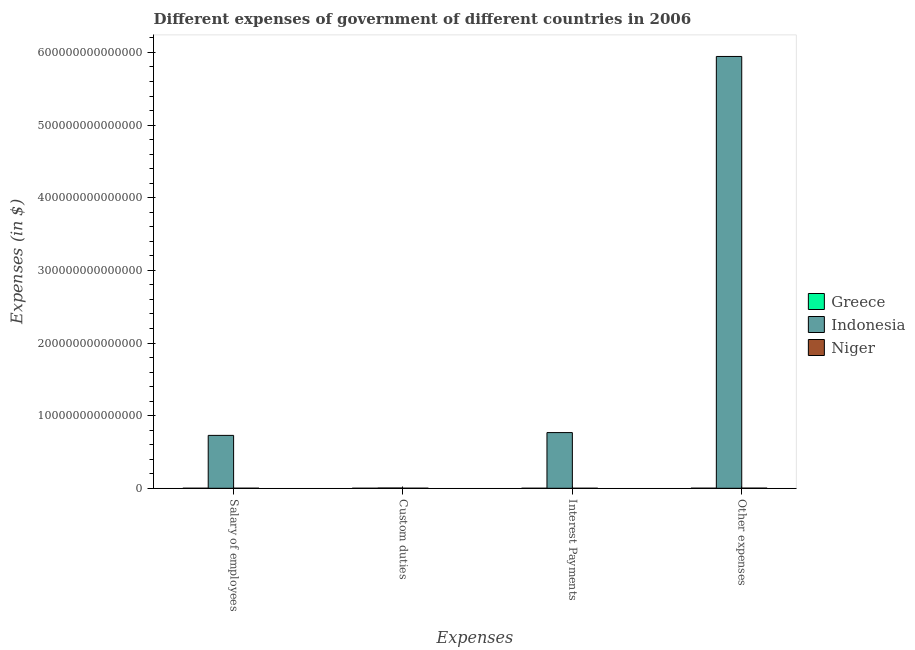How many different coloured bars are there?
Make the answer very short. 3. How many groups of bars are there?
Offer a terse response. 4. What is the label of the 2nd group of bars from the left?
Keep it short and to the point. Custom duties. What is the amount spent on salary of employees in Indonesia?
Your answer should be very brief. 7.28e+13. Across all countries, what is the maximum amount spent on other expenses?
Your answer should be compact. 5.94e+14. Across all countries, what is the minimum amount spent on custom duties?
Provide a succinct answer. 4.00e+06. In which country was the amount spent on other expenses maximum?
Offer a terse response. Indonesia. What is the total amount spent on interest payments in the graph?
Provide a short and direct response. 7.67e+13. What is the difference between the amount spent on interest payments in Greece and that in Niger?
Ensure brevity in your answer.  -1.00e+09. What is the difference between the amount spent on custom duties in Indonesia and the amount spent on salary of employees in Greece?
Ensure brevity in your answer.  3.24e+11. What is the average amount spent on other expenses per country?
Give a very brief answer. 1.98e+14. What is the difference between the amount spent on other expenses and amount spent on custom duties in Indonesia?
Ensure brevity in your answer.  5.94e+14. What is the ratio of the amount spent on custom duties in Greece to that in Indonesia?
Offer a very short reply. 1.1603900029885854e-5. Is the amount spent on custom duties in Indonesia less than that in Niger?
Your answer should be very brief. No. What is the difference between the highest and the second highest amount spent on other expenses?
Give a very brief answer. 5.94e+14. What is the difference between the highest and the lowest amount spent on interest payments?
Ensure brevity in your answer.  7.67e+13. What does the 3rd bar from the left in Interest Payments represents?
Offer a very short reply. Niger. What does the 3rd bar from the right in Salary of employees represents?
Your answer should be compact. Greece. How many bars are there?
Your response must be concise. 12. How many countries are there in the graph?
Keep it short and to the point. 3. What is the difference between two consecutive major ticks on the Y-axis?
Give a very brief answer. 1.00e+14. Are the values on the major ticks of Y-axis written in scientific E-notation?
Your answer should be compact. No. Does the graph contain grids?
Your answer should be compact. No. How many legend labels are there?
Give a very brief answer. 3. What is the title of the graph?
Your response must be concise. Different expenses of government of different countries in 2006. What is the label or title of the X-axis?
Offer a terse response. Expenses. What is the label or title of the Y-axis?
Provide a short and direct response. Expenses (in $). What is the Expenses (in $) in Greece in Salary of employees?
Make the answer very short. 2.10e+1. What is the Expenses (in $) of Indonesia in Salary of employees?
Ensure brevity in your answer.  7.28e+13. What is the Expenses (in $) in Niger in Salary of employees?
Give a very brief answer. 6.80e+1. What is the Expenses (in $) of Greece in Custom duties?
Your response must be concise. 4.00e+06. What is the Expenses (in $) in Indonesia in Custom duties?
Your answer should be compact. 3.45e+11. What is the Expenses (in $) of Niger in Custom duties?
Offer a very short reply. 8.34e+1. What is the Expenses (in $) in Greece in Interest Payments?
Ensure brevity in your answer.  9.73e+09. What is the Expenses (in $) in Indonesia in Interest Payments?
Make the answer very short. 7.67e+13. What is the Expenses (in $) of Niger in Interest Payments?
Offer a very short reply. 1.07e+1. What is the Expenses (in $) of Greece in Other expenses?
Your answer should be very brief. 8.96e+1. What is the Expenses (in $) in Indonesia in Other expenses?
Ensure brevity in your answer.  5.94e+14. What is the Expenses (in $) of Niger in Other expenses?
Make the answer very short. 1.77e+11. Across all Expenses, what is the maximum Expenses (in $) of Greece?
Make the answer very short. 8.96e+1. Across all Expenses, what is the maximum Expenses (in $) in Indonesia?
Your answer should be very brief. 5.94e+14. Across all Expenses, what is the maximum Expenses (in $) of Niger?
Your answer should be compact. 1.77e+11. Across all Expenses, what is the minimum Expenses (in $) of Greece?
Provide a succinct answer. 4.00e+06. Across all Expenses, what is the minimum Expenses (in $) in Indonesia?
Ensure brevity in your answer.  3.45e+11. Across all Expenses, what is the minimum Expenses (in $) in Niger?
Your response must be concise. 1.07e+1. What is the total Expenses (in $) in Greece in the graph?
Your answer should be compact. 1.20e+11. What is the total Expenses (in $) in Indonesia in the graph?
Your answer should be very brief. 7.44e+14. What is the total Expenses (in $) of Niger in the graph?
Offer a very short reply. 3.39e+11. What is the difference between the Expenses (in $) in Greece in Salary of employees and that in Custom duties?
Your response must be concise. 2.10e+1. What is the difference between the Expenses (in $) in Indonesia in Salary of employees and that in Custom duties?
Offer a terse response. 7.25e+13. What is the difference between the Expenses (in $) of Niger in Salary of employees and that in Custom duties?
Your answer should be compact. -1.54e+1. What is the difference between the Expenses (in $) in Greece in Salary of employees and that in Interest Payments?
Provide a succinct answer. 1.13e+1. What is the difference between the Expenses (in $) of Indonesia in Salary of employees and that in Interest Payments?
Make the answer very short. -3.85e+12. What is the difference between the Expenses (in $) in Niger in Salary of employees and that in Interest Payments?
Offer a terse response. 5.72e+1. What is the difference between the Expenses (in $) in Greece in Salary of employees and that in Other expenses?
Keep it short and to the point. -6.86e+1. What is the difference between the Expenses (in $) of Indonesia in Salary of employees and that in Other expenses?
Your answer should be compact. -5.22e+14. What is the difference between the Expenses (in $) of Niger in Salary of employees and that in Other expenses?
Ensure brevity in your answer.  -1.09e+11. What is the difference between the Expenses (in $) in Greece in Custom duties and that in Interest Payments?
Your answer should be compact. -9.72e+09. What is the difference between the Expenses (in $) in Indonesia in Custom duties and that in Interest Payments?
Ensure brevity in your answer.  -7.63e+13. What is the difference between the Expenses (in $) of Niger in Custom duties and that in Interest Payments?
Offer a very short reply. 7.27e+1. What is the difference between the Expenses (in $) in Greece in Custom duties and that in Other expenses?
Your answer should be compact. -8.96e+1. What is the difference between the Expenses (in $) of Indonesia in Custom duties and that in Other expenses?
Give a very brief answer. -5.94e+14. What is the difference between the Expenses (in $) of Niger in Custom duties and that in Other expenses?
Offer a very short reply. -9.35e+1. What is the difference between the Expenses (in $) of Greece in Interest Payments and that in Other expenses?
Ensure brevity in your answer.  -7.98e+1. What is the difference between the Expenses (in $) of Indonesia in Interest Payments and that in Other expenses?
Make the answer very short. -5.18e+14. What is the difference between the Expenses (in $) of Niger in Interest Payments and that in Other expenses?
Give a very brief answer. -1.66e+11. What is the difference between the Expenses (in $) of Greece in Salary of employees and the Expenses (in $) of Indonesia in Custom duties?
Provide a short and direct response. -3.24e+11. What is the difference between the Expenses (in $) of Greece in Salary of employees and the Expenses (in $) of Niger in Custom duties?
Provide a short and direct response. -6.24e+1. What is the difference between the Expenses (in $) of Indonesia in Salary of employees and the Expenses (in $) of Niger in Custom duties?
Ensure brevity in your answer.  7.28e+13. What is the difference between the Expenses (in $) of Greece in Salary of employees and the Expenses (in $) of Indonesia in Interest Payments?
Ensure brevity in your answer.  -7.67e+13. What is the difference between the Expenses (in $) of Greece in Salary of employees and the Expenses (in $) of Niger in Interest Payments?
Offer a very short reply. 1.03e+1. What is the difference between the Expenses (in $) in Indonesia in Salary of employees and the Expenses (in $) in Niger in Interest Payments?
Make the answer very short. 7.28e+13. What is the difference between the Expenses (in $) in Greece in Salary of employees and the Expenses (in $) in Indonesia in Other expenses?
Make the answer very short. -5.94e+14. What is the difference between the Expenses (in $) in Greece in Salary of employees and the Expenses (in $) in Niger in Other expenses?
Provide a succinct answer. -1.56e+11. What is the difference between the Expenses (in $) of Indonesia in Salary of employees and the Expenses (in $) of Niger in Other expenses?
Make the answer very short. 7.27e+13. What is the difference between the Expenses (in $) in Greece in Custom duties and the Expenses (in $) in Indonesia in Interest Payments?
Offer a very short reply. -7.67e+13. What is the difference between the Expenses (in $) in Greece in Custom duties and the Expenses (in $) in Niger in Interest Payments?
Offer a terse response. -1.07e+1. What is the difference between the Expenses (in $) of Indonesia in Custom duties and the Expenses (in $) of Niger in Interest Payments?
Your response must be concise. 3.34e+11. What is the difference between the Expenses (in $) of Greece in Custom duties and the Expenses (in $) of Indonesia in Other expenses?
Your answer should be very brief. -5.94e+14. What is the difference between the Expenses (in $) of Greece in Custom duties and the Expenses (in $) of Niger in Other expenses?
Provide a short and direct response. -1.77e+11. What is the difference between the Expenses (in $) in Indonesia in Custom duties and the Expenses (in $) in Niger in Other expenses?
Offer a terse response. 1.68e+11. What is the difference between the Expenses (in $) of Greece in Interest Payments and the Expenses (in $) of Indonesia in Other expenses?
Provide a short and direct response. -5.94e+14. What is the difference between the Expenses (in $) of Greece in Interest Payments and the Expenses (in $) of Niger in Other expenses?
Provide a short and direct response. -1.67e+11. What is the difference between the Expenses (in $) in Indonesia in Interest Payments and the Expenses (in $) in Niger in Other expenses?
Your answer should be compact. 7.65e+13. What is the average Expenses (in $) in Greece per Expenses?
Offer a terse response. 3.01e+1. What is the average Expenses (in $) of Indonesia per Expenses?
Make the answer very short. 1.86e+14. What is the average Expenses (in $) of Niger per Expenses?
Provide a succinct answer. 8.48e+1. What is the difference between the Expenses (in $) in Greece and Expenses (in $) in Indonesia in Salary of employees?
Provide a short and direct response. -7.28e+13. What is the difference between the Expenses (in $) in Greece and Expenses (in $) in Niger in Salary of employees?
Offer a very short reply. -4.69e+1. What is the difference between the Expenses (in $) of Indonesia and Expenses (in $) of Niger in Salary of employees?
Ensure brevity in your answer.  7.28e+13. What is the difference between the Expenses (in $) in Greece and Expenses (in $) in Indonesia in Custom duties?
Make the answer very short. -3.45e+11. What is the difference between the Expenses (in $) of Greece and Expenses (in $) of Niger in Custom duties?
Your answer should be compact. -8.34e+1. What is the difference between the Expenses (in $) of Indonesia and Expenses (in $) of Niger in Custom duties?
Ensure brevity in your answer.  2.61e+11. What is the difference between the Expenses (in $) in Greece and Expenses (in $) in Indonesia in Interest Payments?
Offer a terse response. -7.67e+13. What is the difference between the Expenses (in $) in Greece and Expenses (in $) in Niger in Interest Payments?
Ensure brevity in your answer.  -1.00e+09. What is the difference between the Expenses (in $) in Indonesia and Expenses (in $) in Niger in Interest Payments?
Your answer should be compact. 7.67e+13. What is the difference between the Expenses (in $) of Greece and Expenses (in $) of Indonesia in Other expenses?
Provide a short and direct response. -5.94e+14. What is the difference between the Expenses (in $) of Greece and Expenses (in $) of Niger in Other expenses?
Ensure brevity in your answer.  -8.74e+1. What is the difference between the Expenses (in $) of Indonesia and Expenses (in $) of Niger in Other expenses?
Provide a short and direct response. 5.94e+14. What is the ratio of the Expenses (in $) in Greece in Salary of employees to that in Custom duties?
Offer a very short reply. 5255. What is the ratio of the Expenses (in $) of Indonesia in Salary of employees to that in Custom duties?
Make the answer very short. 211.3. What is the ratio of the Expenses (in $) of Niger in Salary of employees to that in Custom duties?
Your answer should be very brief. 0.81. What is the ratio of the Expenses (in $) in Greece in Salary of employees to that in Interest Payments?
Make the answer very short. 2.16. What is the ratio of the Expenses (in $) of Indonesia in Salary of employees to that in Interest Payments?
Your answer should be very brief. 0.95. What is the ratio of the Expenses (in $) of Niger in Salary of employees to that in Interest Payments?
Ensure brevity in your answer.  6.34. What is the ratio of the Expenses (in $) of Greece in Salary of employees to that in Other expenses?
Provide a short and direct response. 0.23. What is the ratio of the Expenses (in $) of Indonesia in Salary of employees to that in Other expenses?
Keep it short and to the point. 0.12. What is the ratio of the Expenses (in $) of Niger in Salary of employees to that in Other expenses?
Give a very brief answer. 0.38. What is the ratio of the Expenses (in $) of Indonesia in Custom duties to that in Interest Payments?
Keep it short and to the point. 0. What is the ratio of the Expenses (in $) in Niger in Custom duties to that in Interest Payments?
Your answer should be compact. 7.77. What is the ratio of the Expenses (in $) in Greece in Custom duties to that in Other expenses?
Offer a very short reply. 0. What is the ratio of the Expenses (in $) of Indonesia in Custom duties to that in Other expenses?
Keep it short and to the point. 0. What is the ratio of the Expenses (in $) of Niger in Custom duties to that in Other expenses?
Provide a short and direct response. 0.47. What is the ratio of the Expenses (in $) of Greece in Interest Payments to that in Other expenses?
Offer a terse response. 0.11. What is the ratio of the Expenses (in $) in Indonesia in Interest Payments to that in Other expenses?
Your response must be concise. 0.13. What is the ratio of the Expenses (in $) in Niger in Interest Payments to that in Other expenses?
Ensure brevity in your answer.  0.06. What is the difference between the highest and the second highest Expenses (in $) of Greece?
Provide a short and direct response. 6.86e+1. What is the difference between the highest and the second highest Expenses (in $) in Indonesia?
Keep it short and to the point. 5.18e+14. What is the difference between the highest and the second highest Expenses (in $) in Niger?
Provide a short and direct response. 9.35e+1. What is the difference between the highest and the lowest Expenses (in $) in Greece?
Provide a short and direct response. 8.96e+1. What is the difference between the highest and the lowest Expenses (in $) in Indonesia?
Your answer should be compact. 5.94e+14. What is the difference between the highest and the lowest Expenses (in $) of Niger?
Keep it short and to the point. 1.66e+11. 